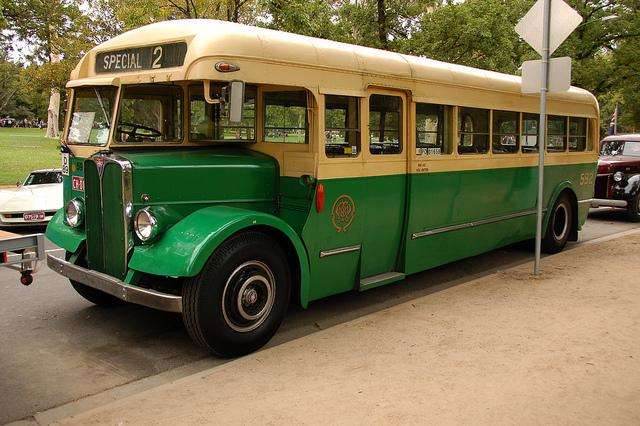Where will the passengers enter? side door 